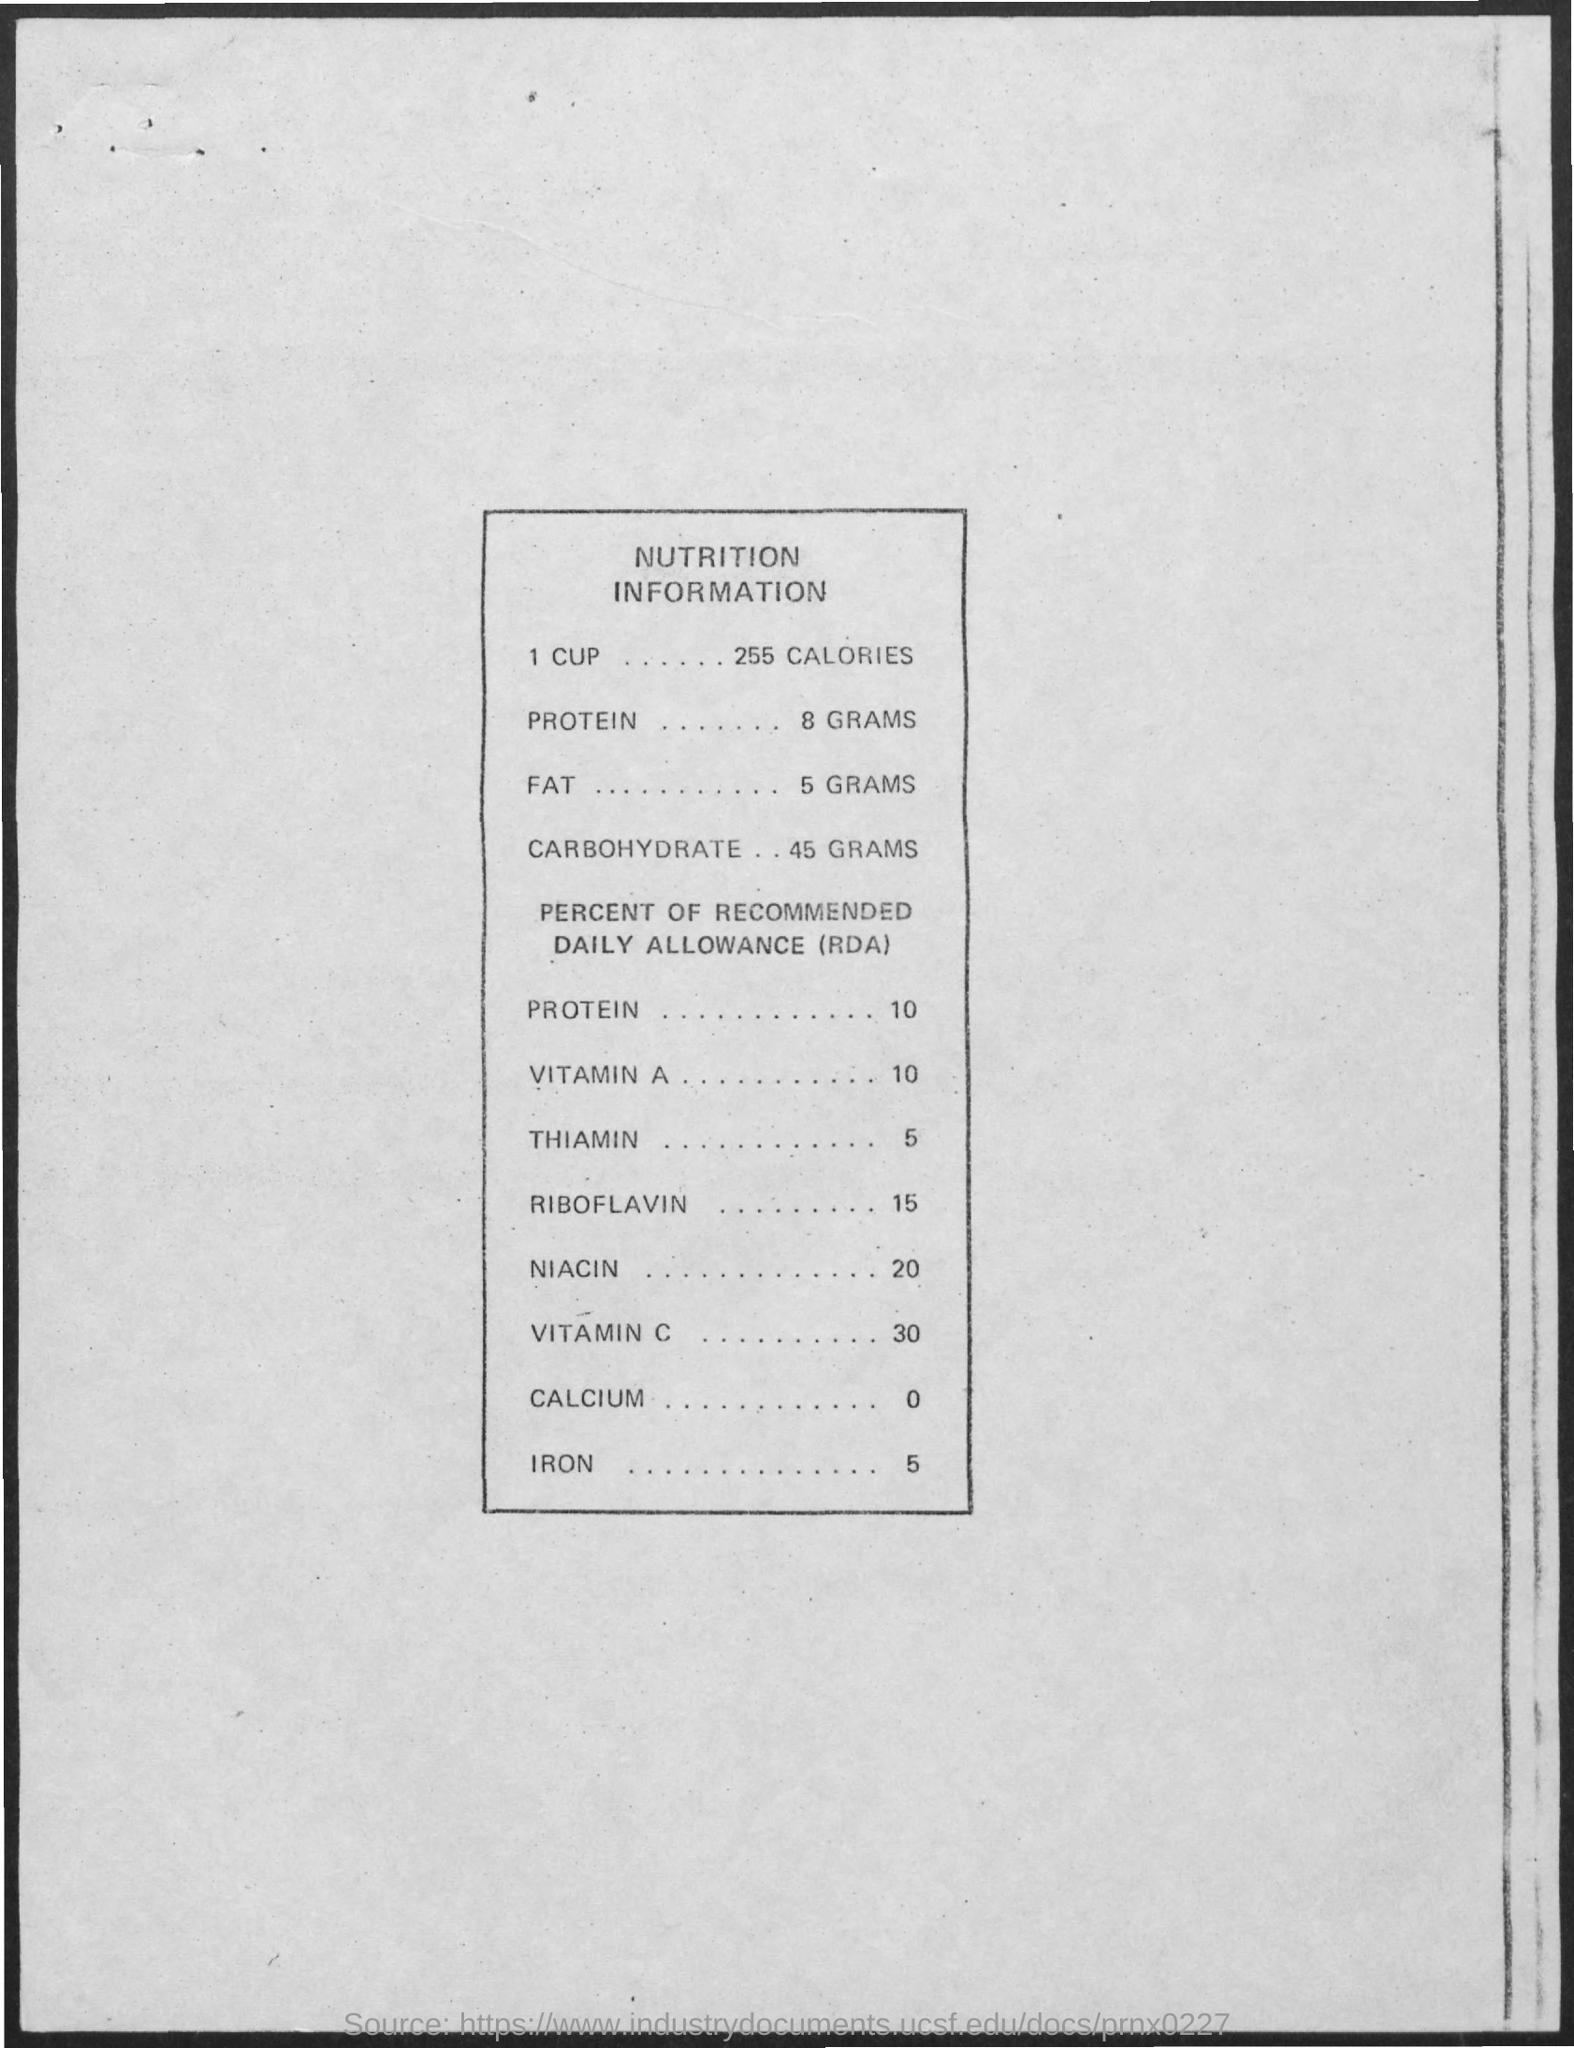Draw attention to some important aspects in this diagram. The information mentioned in the given page is nutrition information. The recommended daily amount of riboflavin required for adults is 15% of the Reference Daily Intake (RDI). The equivalent amount of carbohydrates would be 45 grams. The daily allowance of vitamin C needed for health is approximately 30%. The amount of vitamin A required for recommended daily allowance (RDA) is 10%. 